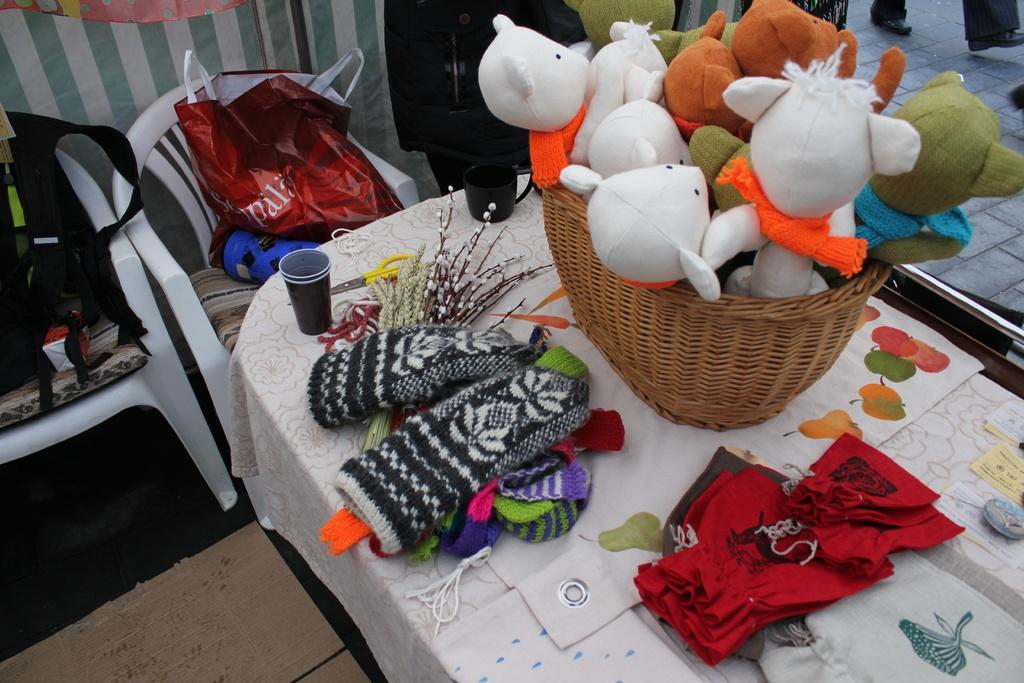What objects can be seen in the image? There are toys in the image. What items are on the table in the image? There are woolen clothes on the table. What furniture can be seen in the background of the image? There are chairs in the background of the image. What type of textile is present in the background of the image? There are covers in the background of the image. What window treatment is associated with the window in the background of the image? There is a curtain associated with a window in the background of the image. Can you describe the window in the background of the image? There is a window in the background of the image. What type of pot is used for religious ceremonies in the image? There is no pot or religious ceremony present in the image. How many trucks are visible in the image? There are no trucks visible in the image. 